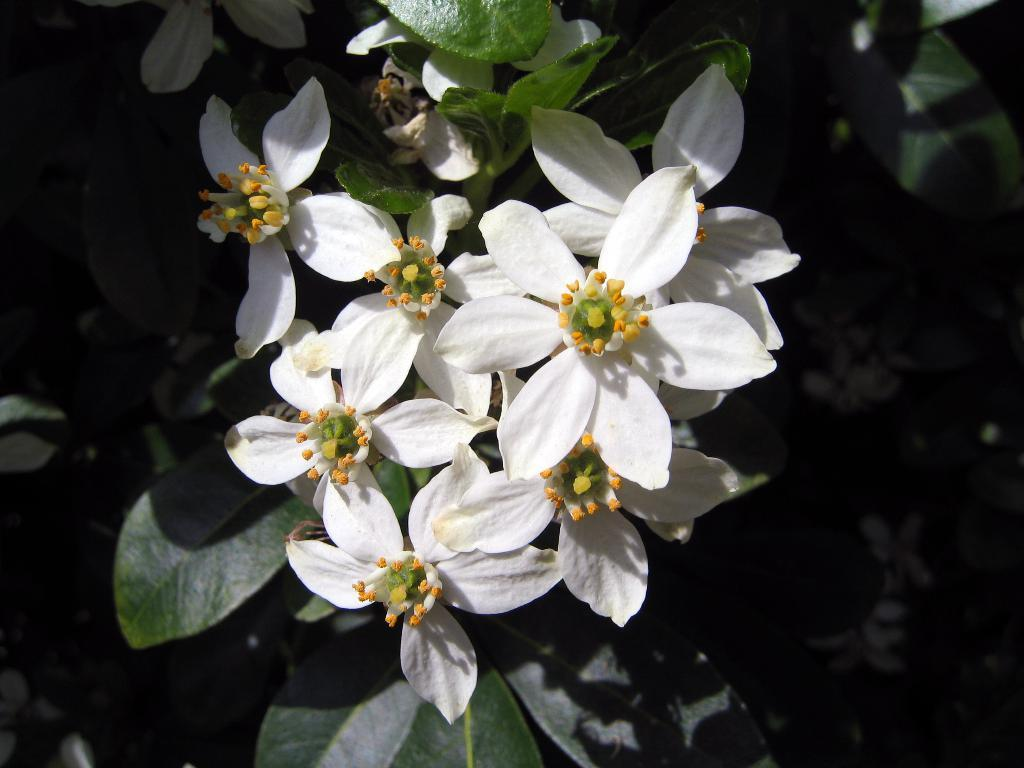What type of flowers can be seen in the image? There are white flowers in the image. What else is present in the image besides the flowers? There are leaves in the image. What is the level of friction between the flowers and the leaves in the image? The level of friction between the flowers and the leaves cannot be determined from the image, as it does not provide any information about their physical interaction. 